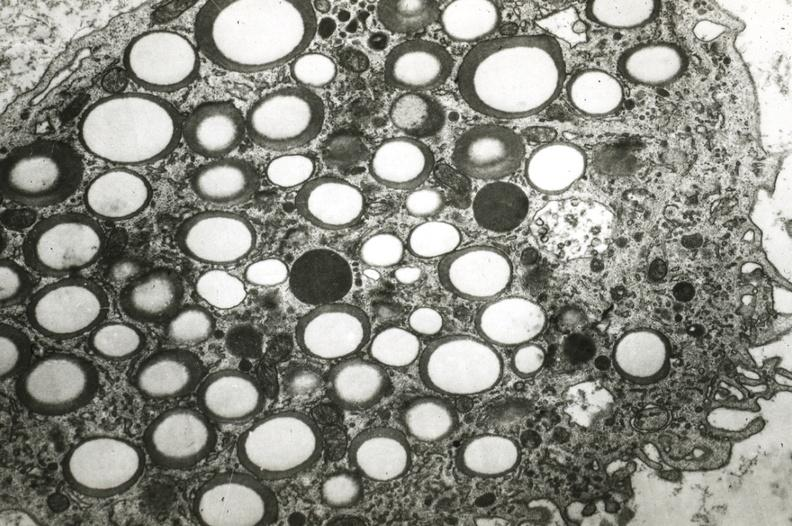does carcinomatosis show foam cell?
Answer the question using a single word or phrase. No 